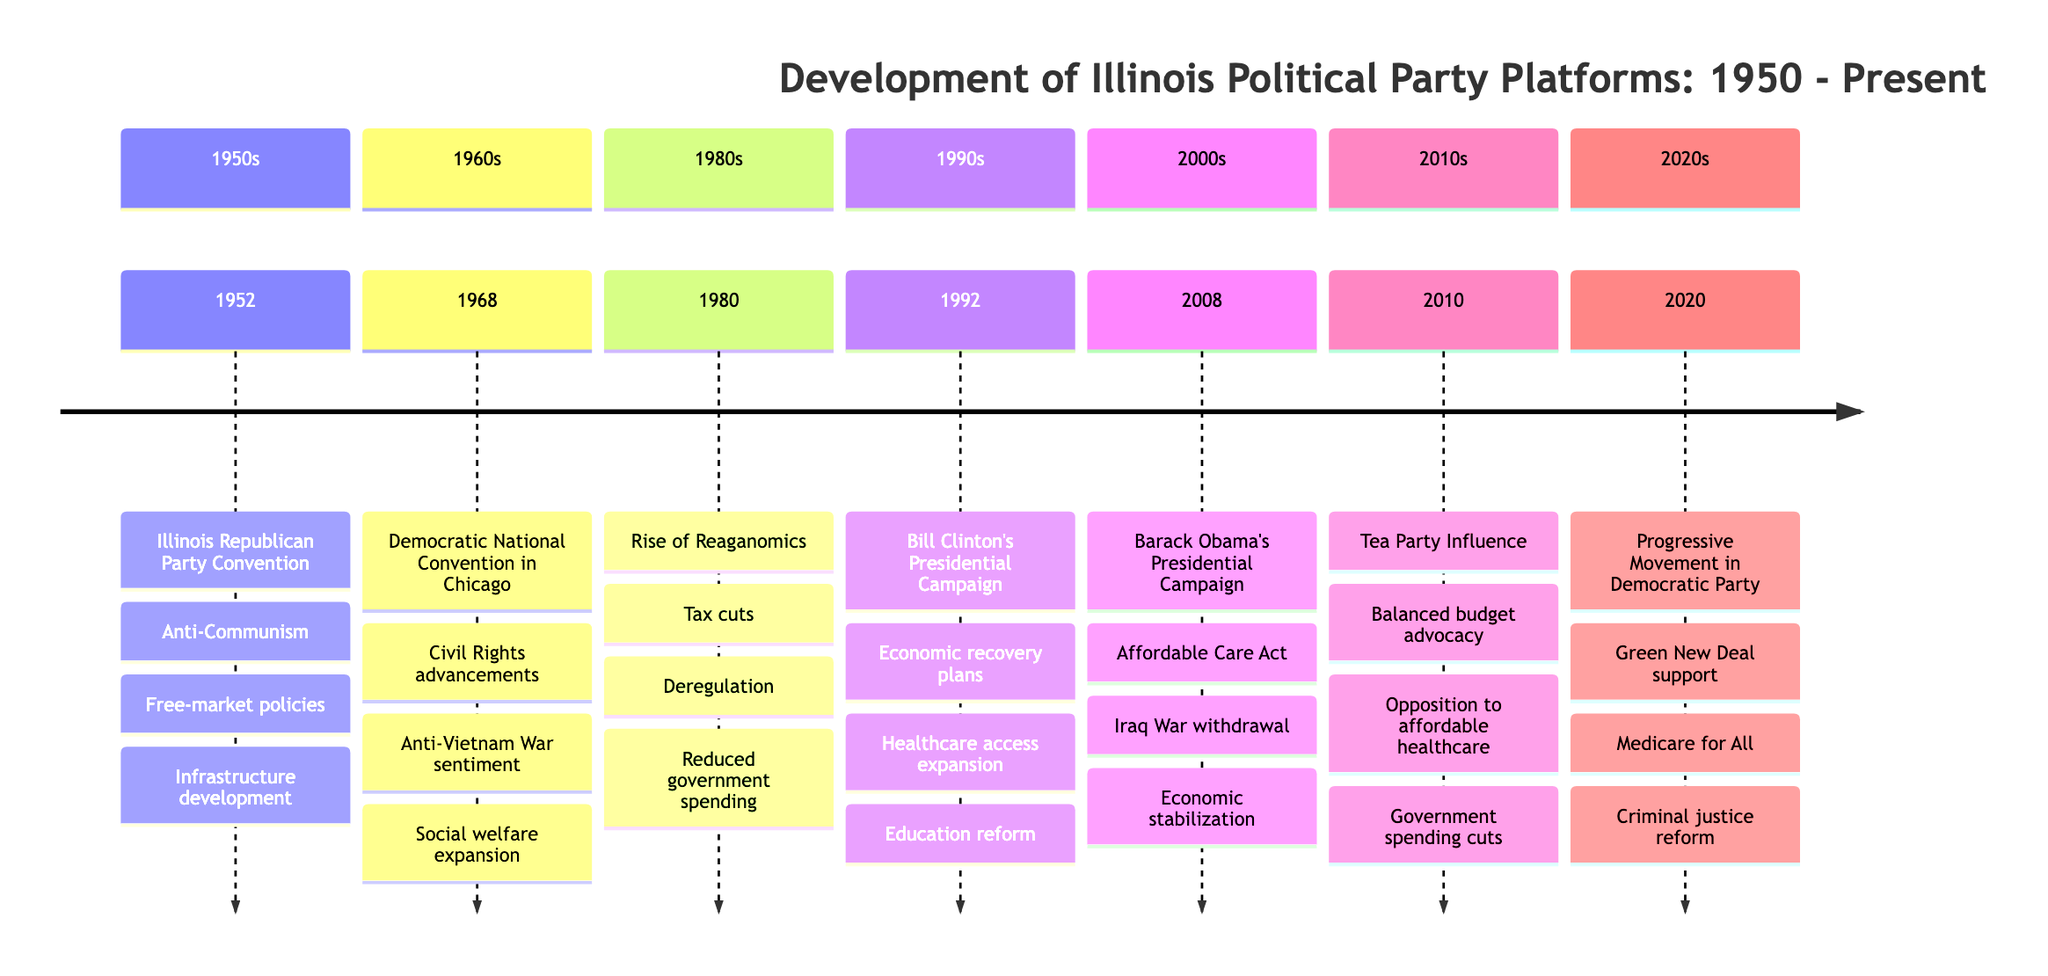What was a key focus of the Illinois Republican Party Convention in 1952? The event details state that the party focused on Anti-Communism and economic growth. Specifically, one of the key points listed is a strong stance against Communism.
Answer: Anti-Communism What major ideological shift occurred within the Illinois Republicans in 1980? The event details indicate that in 1980, during the rise of Reaganomics, the Illinois Republicans adopted policies emphasizing tax cuts, deregulation, and reducing government spending, which represents a shift towards a more market-oriented ideology.
Answer: Reaganomics How many main events are documented in the timeline? By counting the individual events provided in the timeline data, we find that there are a total of 7 distinct events listed.
Answer: 7 What was a primary point of the Democratic platform during the 1992 campaign? The key points listed under the 1992 event highlight economic recovery plans as a major aspect of the Democratic platform during Bill Clinton's campaign in Illinois.
Answer: Economic recovery plans What consistent element appeared in the Democratic platforms noted across the timeline? Reviewing the key points from both the 1968 and 2008 events shows that healthcare reform was a consistent element, with a significant focus on healthcare access in 1992 and the Affordable Care Act in 2008.
Answer: Healthcare reform During which event did Illinois Democrats embrace the Green New Deal? According to the 2020 event entry, it was during the Progressive Movement in the Democratic Party that they notably supported the Green New Deal.
Answer: 2020 What shift in Republican ideology is highlighted in 2010? The 2010 event details mention the influence of the Tea Party, which emphasized a move towards fiscal conservatism and a reduction in the size of government.
Answer: Fiscal conservatism Which year marked a major protest at a Democratic convention in Illinois? The timeline specifies that protests and police clashes occurred during the Democratic National Convention in Chicago in 1968, highlighting a significant moment of dissent.
Answer: 1968 What aspect of Barack Obama's campaign in 2008 was particularly notable? The details for the 2008 event indicate that one notable aspect was his emphasis on change and hope, particularly focusing on healthcare reform.
Answer: Healthcare reform 